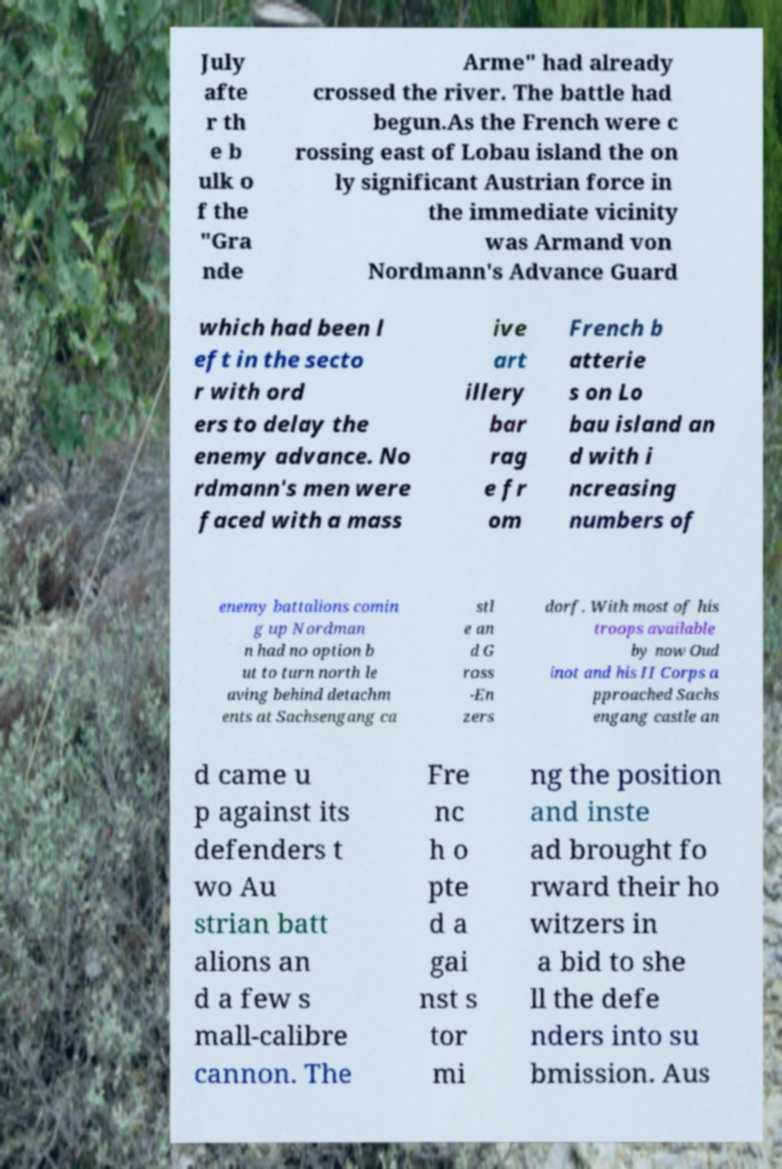Could you extract and type out the text from this image? July afte r th e b ulk o f the "Gra nde Arme" had already crossed the river. The battle had begun.As the French were c rossing east of Lobau island the on ly significant Austrian force in the immediate vicinity was Armand von Nordmann's Advance Guard which had been l eft in the secto r with ord ers to delay the enemy advance. No rdmann's men were faced with a mass ive art illery bar rag e fr om French b atterie s on Lo bau island an d with i ncreasing numbers of enemy battalions comin g up Nordman n had no option b ut to turn north le aving behind detachm ents at Sachsengang ca stl e an d G ross -En zers dorf. With most of his troops available by now Oud inot and his II Corps a pproached Sachs engang castle an d came u p against its defenders t wo Au strian batt alions an d a few s mall-calibre cannon. The Fre nc h o pte d a gai nst s tor mi ng the position and inste ad brought fo rward their ho witzers in a bid to she ll the defe nders into su bmission. Aus 